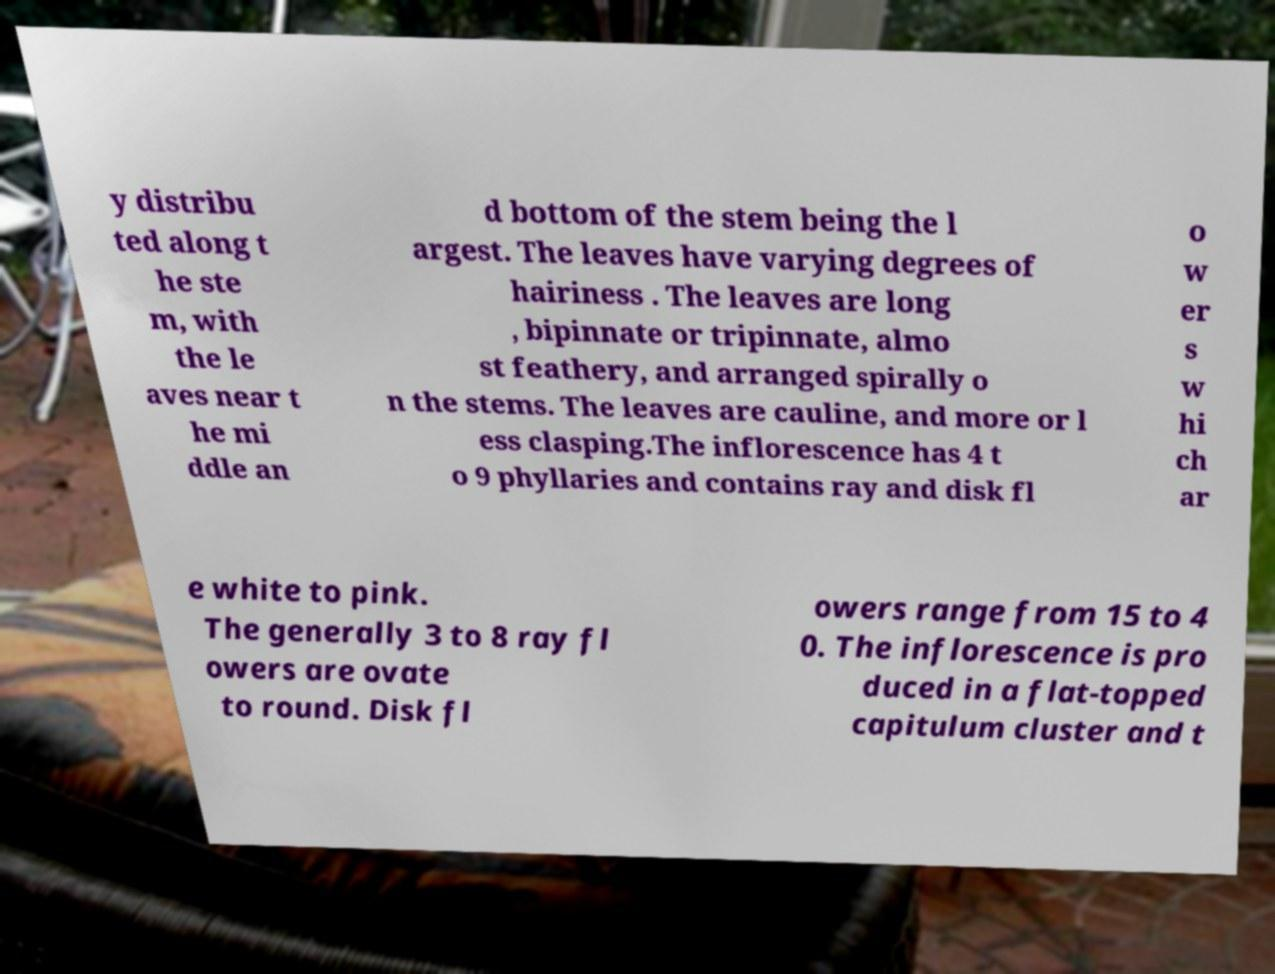For documentation purposes, I need the text within this image transcribed. Could you provide that? y distribu ted along t he ste m, with the le aves near t he mi ddle an d bottom of the stem being the l argest. The leaves have varying degrees of hairiness . The leaves are long , bipinnate or tripinnate, almo st feathery, and arranged spirally o n the stems. The leaves are cauline, and more or l ess clasping.The inflorescence has 4 t o 9 phyllaries and contains ray and disk fl o w er s w hi ch ar e white to pink. The generally 3 to 8 ray fl owers are ovate to round. Disk fl owers range from 15 to 4 0. The inflorescence is pro duced in a flat-topped capitulum cluster and t 